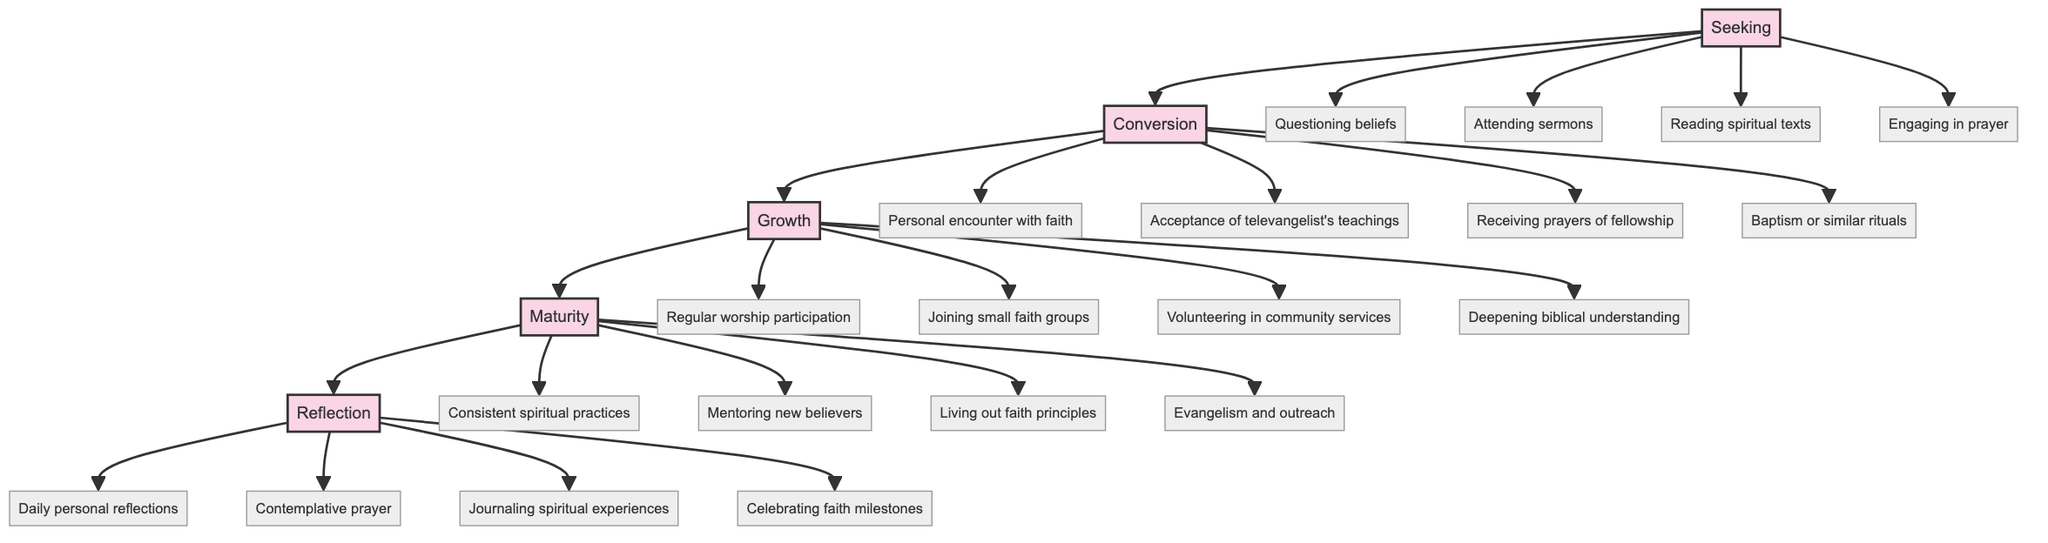What are the stages in the spiritual journey mapping? The diagram displays five stages of the spiritual journey: Seeking, Conversion, Growth, Maturity, and Reflection.
Answer: Seeking, Conversion, Growth, Maturity, Reflection How many elements are in the Growth stage? The Growth stage contains four elements: Regular worship participation, Joining small faith groups, Volunteering in community services, and Deepening biblical understanding.
Answer: 4 What is the first element of the Maturity stage? The first element listed under the Maturity stage is Consistent spiritual practices.
Answer: Consistent spiritual practices Which stage comes after Conversion? The stage that directly follows Conversion in the diagram is Growth.
Answer: Growth What is the last element in the Reflection stage? The last element in the Reflection stage is Celebrating faith milestones.
Answer: Celebrating faith milestones What do the elements of the Seeking stage focus on? The elements of the Seeking stage focus on questioning beliefs, attending sermons, reading spiritual texts, and engaging in prayer.
Answer: Questioning beliefs, attending sermons, reading spiritual texts, engaging in prayer Which stage has mentoring new believers as an element? The Maturity stage includes mentoring new believers as one of its elements.
Answer: Maturity How many total stages are represented in the diagram? There are five total stages represented in the diagram.
Answer: 5 What element is directly associated with receiving prayers of fellowship? The element associated with receiving prayers of fellowship is in the Conversion stage.
Answer: Conversion 